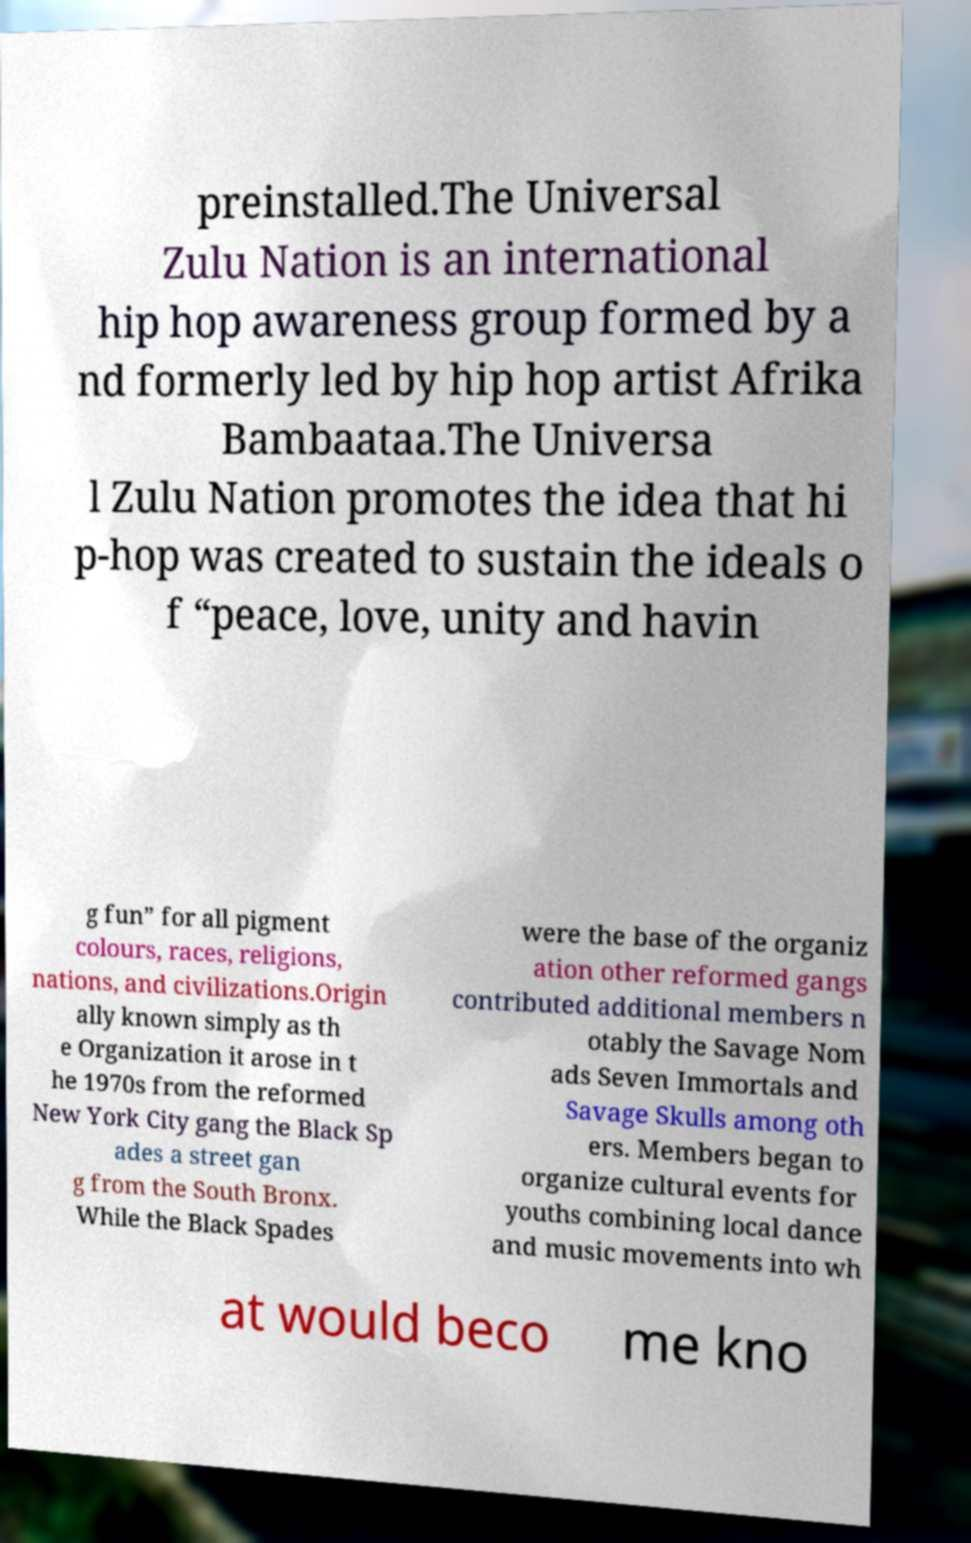Please read and relay the text visible in this image. What does it say? preinstalled.The Universal Zulu Nation is an international hip hop awareness group formed by a nd formerly led by hip hop artist Afrika Bambaataa.The Universa l Zulu Nation promotes the idea that hi p-hop was created to sustain the ideals o f “peace, love, unity and havin g fun” for all pigment colours, races, religions, nations, and civilizations.Origin ally known simply as th e Organization it arose in t he 1970s from the reformed New York City gang the Black Sp ades a street gan g from the South Bronx. While the Black Spades were the base of the organiz ation other reformed gangs contributed additional members n otably the Savage Nom ads Seven Immortals and Savage Skulls among oth ers. Members began to organize cultural events for youths combining local dance and music movements into wh at would beco me kno 